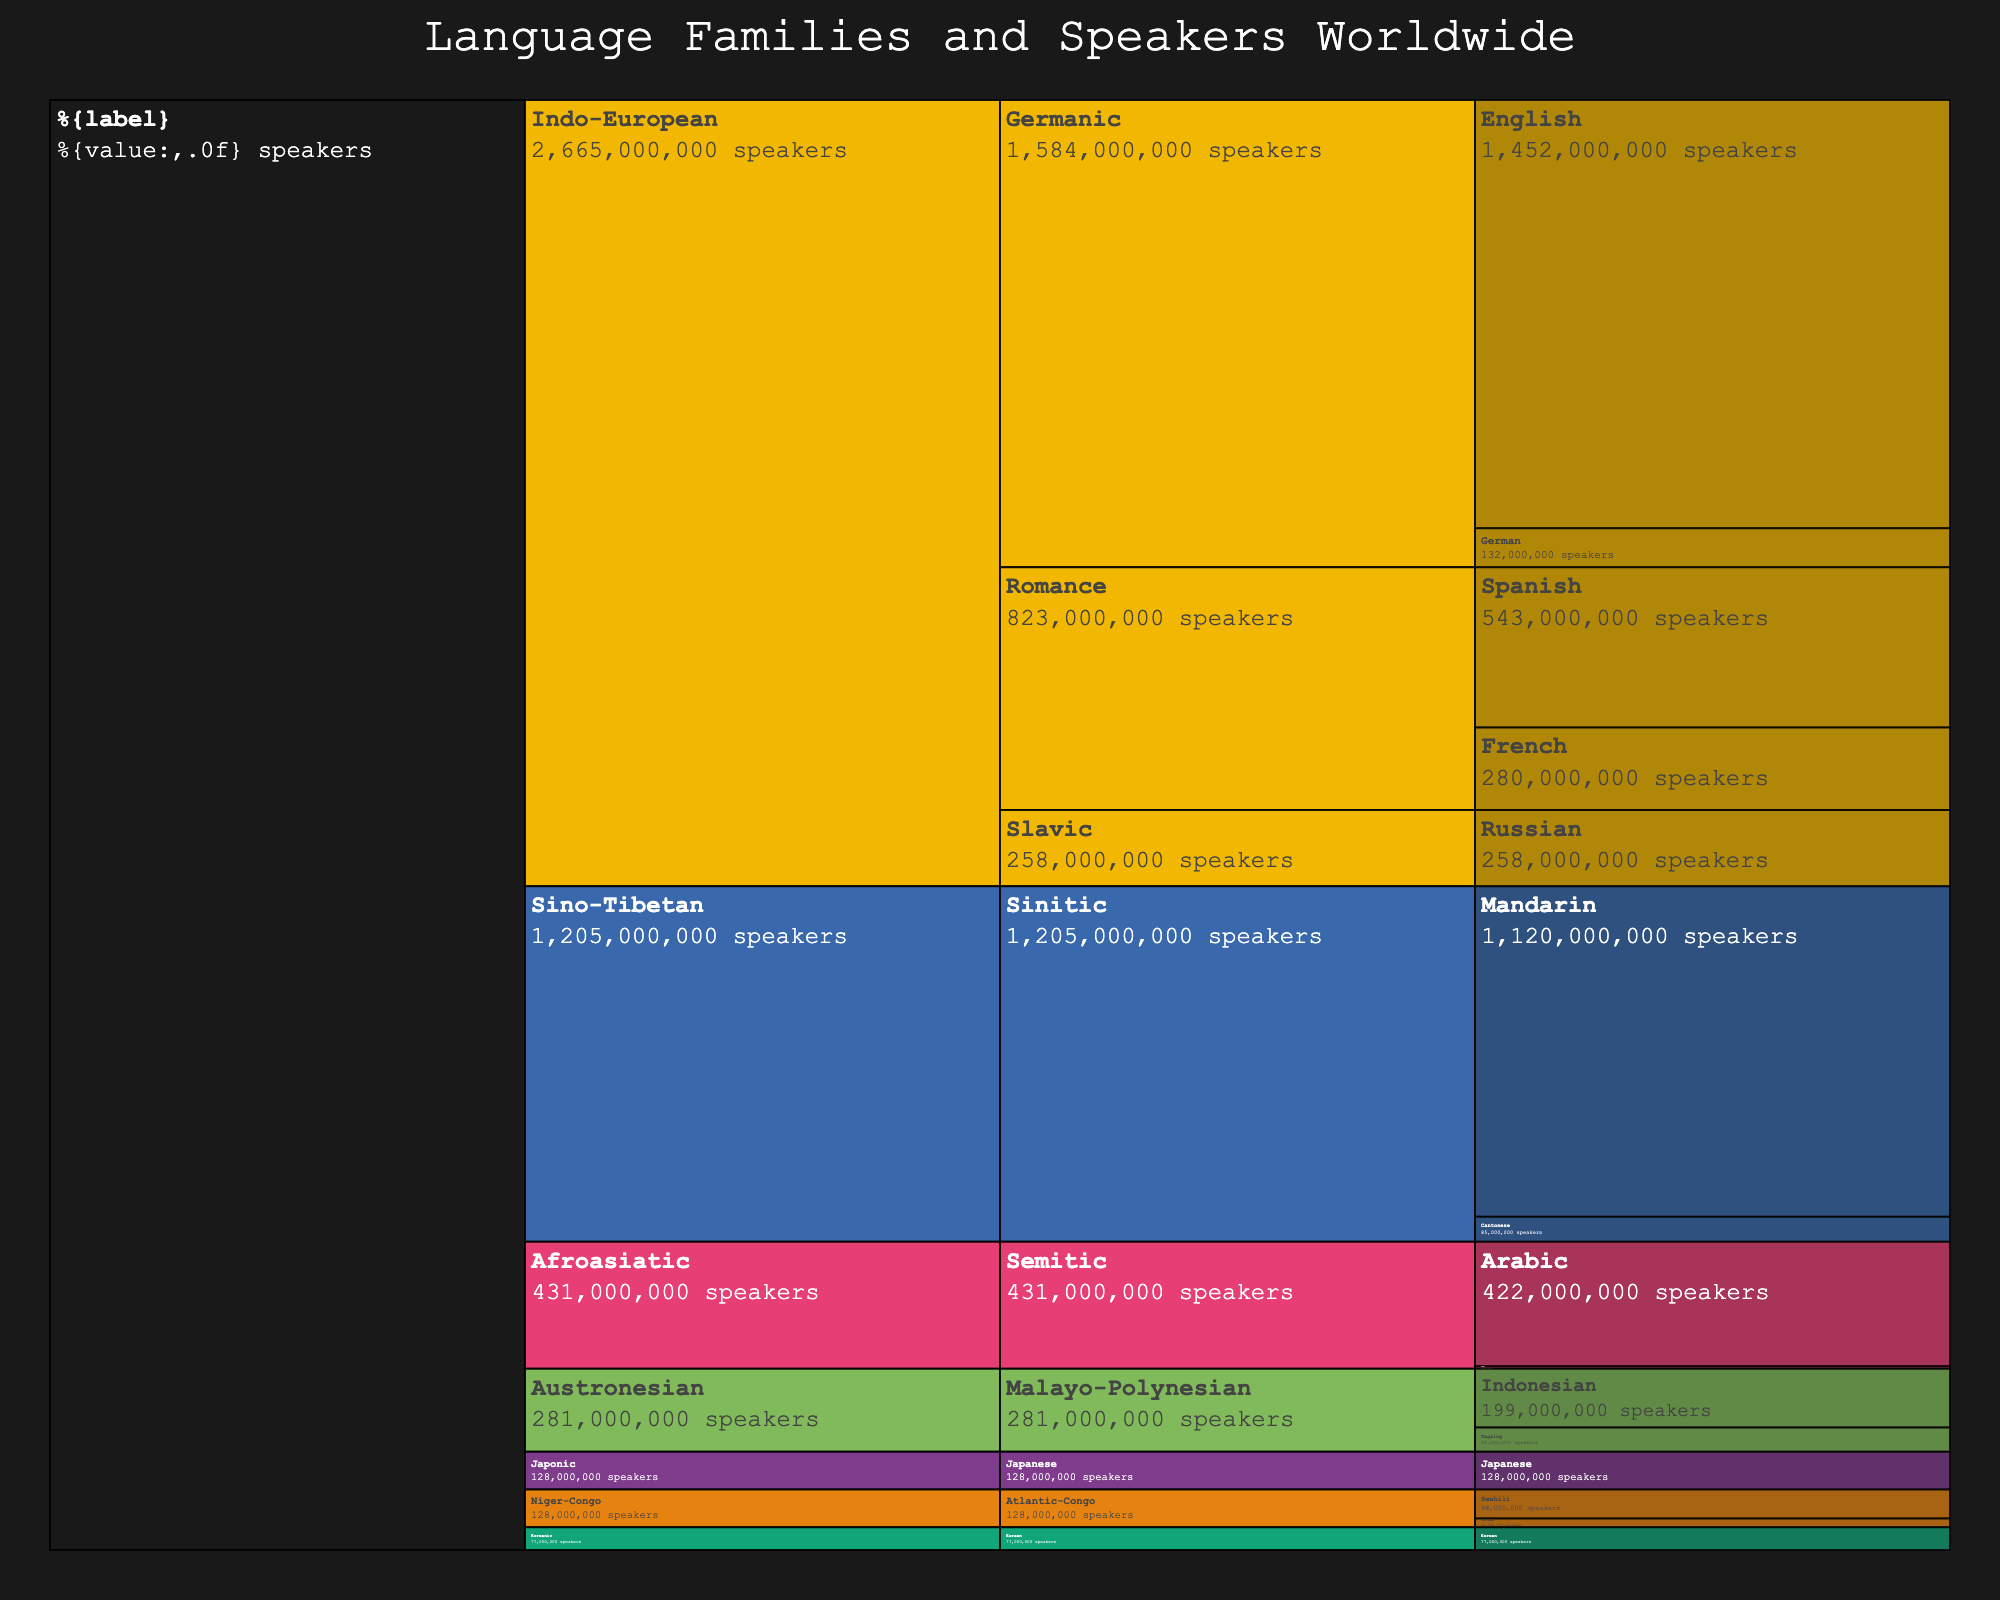How many language families are depicted in the chart? Look at the top-most layer of the icicle chart to identify the number of unique language families.
Answer: 6 Which language has the highest number of speakers? Find the language with the largest value in the speaker count from the innermost layer of the chart.
Answer: English What's the combined number of speakers for the Germanic sub-family of the Indo-European language family? Add the number of speakers of English and German: 1452000000 + 132000000 = 1584000000
Answer: 1584000000 How do the numbers of speakers for Mandarin and Spanish compare? Compare the speaker counts directly from the chart: Mandarin (1120000000) vs Spanish (543000000).
Answer: Mandarin has more speakers What’s the total number of speakers in the Afroasiatic language family? Sum the speaker counts for Arabic and Hebrew: 422000000 + 9000000 = 431000000
Answer: 431000000 Which sub-family under the Indo-European family has the fewest number of speakers? Compare the aggregate speaker counts for Germanic, Romance, and Slavic sub-families in the Indo-European family.
Answer: Slavic Is the number of speakers of the Japanese language greater than the number of speakers of Swahili and Tagalog combined? Compare Japanese speakers (128000000) vs the combined speakers of Swahili (98000000) + Tagalog (82000000) = 180000000.
Answer: No What is the ratio of speakers between English and Arabic? Divide the number of English speakers by the number of Arabic speakers: 1452000000 / 422000000 ≈ 3.44
Answer: 3.44 Identify the language sub-family within the Sino-Tibetan family with the most speakers. Observe the sub-families under the Sino-Tibetan family and compare their speaker counts.
Answer: Sinitic 